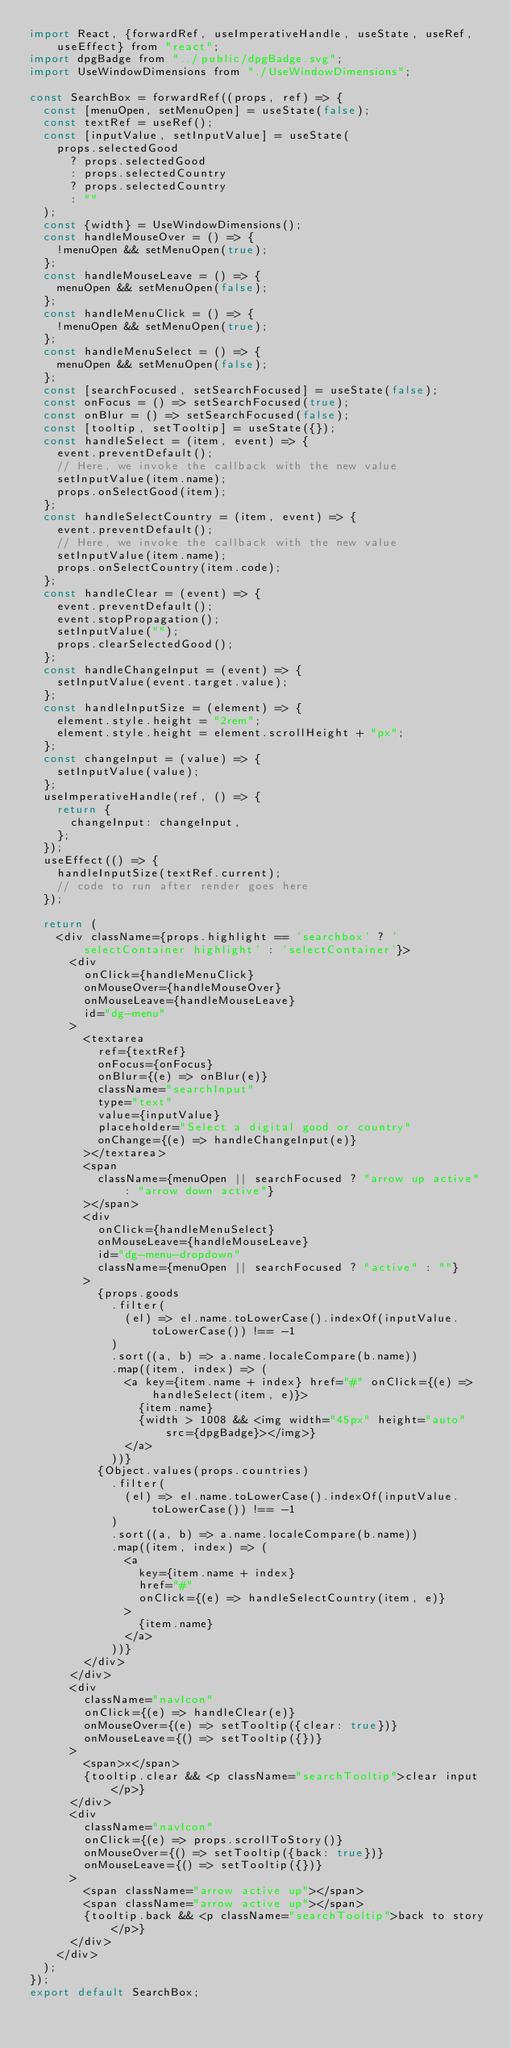<code> <loc_0><loc_0><loc_500><loc_500><_JavaScript_>import React, {forwardRef, useImperativeHandle, useState, useRef, useEffect} from "react";
import dpgBadge from "../public/dpgBadge.svg";
import UseWindowDimensions from "./UseWindowDimensions";

const SearchBox = forwardRef((props, ref) => {
  const [menuOpen, setMenuOpen] = useState(false);
  const textRef = useRef();
  const [inputValue, setInputValue] = useState(
    props.selectedGood
      ? props.selectedGood
      : props.selectedCountry
      ? props.selectedCountry
      : ""
  );
  const {width} = UseWindowDimensions();
  const handleMouseOver = () => {
    !menuOpen && setMenuOpen(true);
  };
  const handleMouseLeave = () => {
    menuOpen && setMenuOpen(false);
  };
  const handleMenuClick = () => {
    !menuOpen && setMenuOpen(true);
  };
  const handleMenuSelect = () => {
    menuOpen && setMenuOpen(false);
  };
  const [searchFocused, setSearchFocused] = useState(false);
  const onFocus = () => setSearchFocused(true);
  const onBlur = () => setSearchFocused(false);
  const [tooltip, setTooltip] = useState({});
  const handleSelect = (item, event) => {
    event.preventDefault();
    // Here, we invoke the callback with the new value
    setInputValue(item.name);
    props.onSelectGood(item);
  };
  const handleSelectCountry = (item, event) => {
    event.preventDefault();
    // Here, we invoke the callback with the new value
    setInputValue(item.name);
    props.onSelectCountry(item.code);
  };
  const handleClear = (event) => {
    event.preventDefault();
    event.stopPropagation();
    setInputValue("");
    props.clearSelectedGood();
  };
  const handleChangeInput = (event) => {
    setInputValue(event.target.value);
  };
  const handleInputSize = (element) => {
    element.style.height = "2rem";
    element.style.height = element.scrollHeight + "px";
  };
  const changeInput = (value) => {
    setInputValue(value);
  };
  useImperativeHandle(ref, () => {
    return {
      changeInput: changeInput,
    };
  });
  useEffect(() => {
    handleInputSize(textRef.current);
    // code to run after render goes here
  });

  return (
    <div className={props.highlight == 'searchbox' ? 'selectContainer highlight' : 'selectContainer'}>
      <div
        onClick={handleMenuClick}
        onMouseOver={handleMouseOver}
        onMouseLeave={handleMouseLeave}
        id="dg-menu"
      >
        <textarea
          ref={textRef}
          onFocus={onFocus}
          onBlur={(e) => onBlur(e)}
          className="searchInput"
          type="text"
          value={inputValue}
          placeholder="Select a digital good or country"
          onChange={(e) => handleChangeInput(e)}
        ></textarea>
        <span
          className={menuOpen || searchFocused ? "arrow up active" : "arrow down active"}
        ></span>
        <div
          onClick={handleMenuSelect}
          onMouseLeave={handleMouseLeave}
          id="dg-menu-dropdown"
          className={menuOpen || searchFocused ? "active" : ""}
        >
          {props.goods
            .filter(
              (el) => el.name.toLowerCase().indexOf(inputValue.toLowerCase()) !== -1
            )
            .sort((a, b) => a.name.localeCompare(b.name))
            .map((item, index) => (
              <a key={item.name + index} href="#" onClick={(e) => handleSelect(item, e)}>
                {item.name}
                {width > 1008 && <img width="45px" height="auto" src={dpgBadge}></img>}
              </a>
            ))}
          {Object.values(props.countries)
            .filter(
              (el) => el.name.toLowerCase().indexOf(inputValue.toLowerCase()) !== -1
            )
            .sort((a, b) => a.name.localeCompare(b.name))
            .map((item, index) => (
              <a
                key={item.name + index}
                href="#"
                onClick={(e) => handleSelectCountry(item, e)}
              >
                {item.name}
              </a>
            ))}
        </div>
      </div>
      <div
        className="navIcon"
        onClick={(e) => handleClear(e)}
        onMouseOver={(e) => setTooltip({clear: true})}
        onMouseLeave={() => setTooltip({})}
      >
        <span>x</span>
        {tooltip.clear && <p className="searchTooltip">clear input</p>}
      </div>
      <div
        className="navIcon"
        onClick={(e) => props.scrollToStory()}
        onMouseOver={() => setTooltip({back: true})}
        onMouseLeave={() => setTooltip({})}
      >
        <span className="arrow active up"></span>
        <span className="arrow active up"></span>
        {tooltip.back && <p className="searchTooltip">back to story</p>}
      </div>
    </div>
  );
});
export default SearchBox;
</code> 